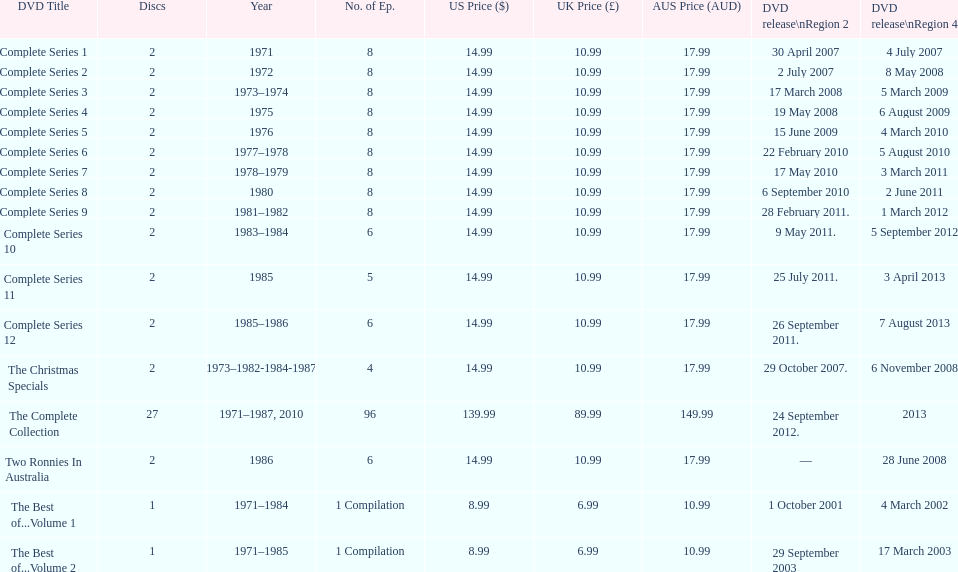Parse the table in full. {'header': ['DVD Title', 'Discs', 'Year', 'No. of Ep.', 'US Price ($)', 'UK Price (£)', 'AUS Price (AUD)', 'DVD release\\nRegion 2', 'DVD release\\nRegion 4'], 'rows': [['Complete Series 1', '2', '1971', '8', '14.99', '10.99', '17.99', '30 April 2007', '4 July 2007'], ['Complete Series 2', '2', '1972', '8', '14.99', '10.99', '17.99', '2 July 2007', '8 May 2008'], ['Complete Series 3', '2', '1973–1974', '8', '14.99', '10.99', '17.99', '17 March 2008', '5 March 2009'], ['Complete Series 4', '2', '1975', '8', '14.99', '10.99', '17.99', '19 May 2008', '6 August 2009'], ['Complete Series 5', '2', '1976', '8', '14.99', '10.99', '17.99', '15 June 2009', '4 March 2010'], ['Complete Series 6', '2', '1977–1978', '8', '14.99', '10.99', '17.99', '22 February 2010', '5 August 2010'], ['Complete Series 7', '2', '1978–1979', '8', '14.99', '10.99', '17.99', '17 May 2010', '3 March 2011'], ['Complete Series 8', '2', '1980', '8', '14.99', '10.99', '17.99', '6 September 2010', '2 June 2011'], ['Complete Series 9', '2', '1981–1982', '8', '14.99', '10.99', '17.99', '28 February 2011.', '1 March 2012'], ['Complete Series 10', '2', '1983–1984', '6', '14.99', '10.99', '17.99', '9 May 2011.', '5 September 2012'], ['Complete Series 11', '2', '1985', '5', '14.99', '10.99', '17.99', '25 July 2011.', '3 April 2013'], ['Complete Series 12', '2', '1985–1986', '6', '14.99', '10.99', '17.99', '26 September 2011.', '7 August 2013'], ['The Christmas Specials', '2', '1973–1982-1984-1987', '4', '14.99', '10.99', '17.99', '29 October 2007.', '6 November 2008'], ['The Complete Collection', '27', '1971–1987, 2010', '96', '139.99', '89.99', '149.99', '24 September 2012.', '2013'], ['Two Ronnies In Australia', '2', '1986', '6', '14.99', '10.99', '17.99', '—', '28 June 2008'], ['The Best of...Volume 1', '1', '1971–1984', '1 Compilation', '8.99', '6.99', '10.99', '1 October 2001', '4 March 2002'], ['The Best of...Volume 2', '1', '1971–1985', '1 Compilation', '8.99', '6.99', '10.99', '29 September 2003', '17 March 2003']]} How many series had 8 episodes? 9. 